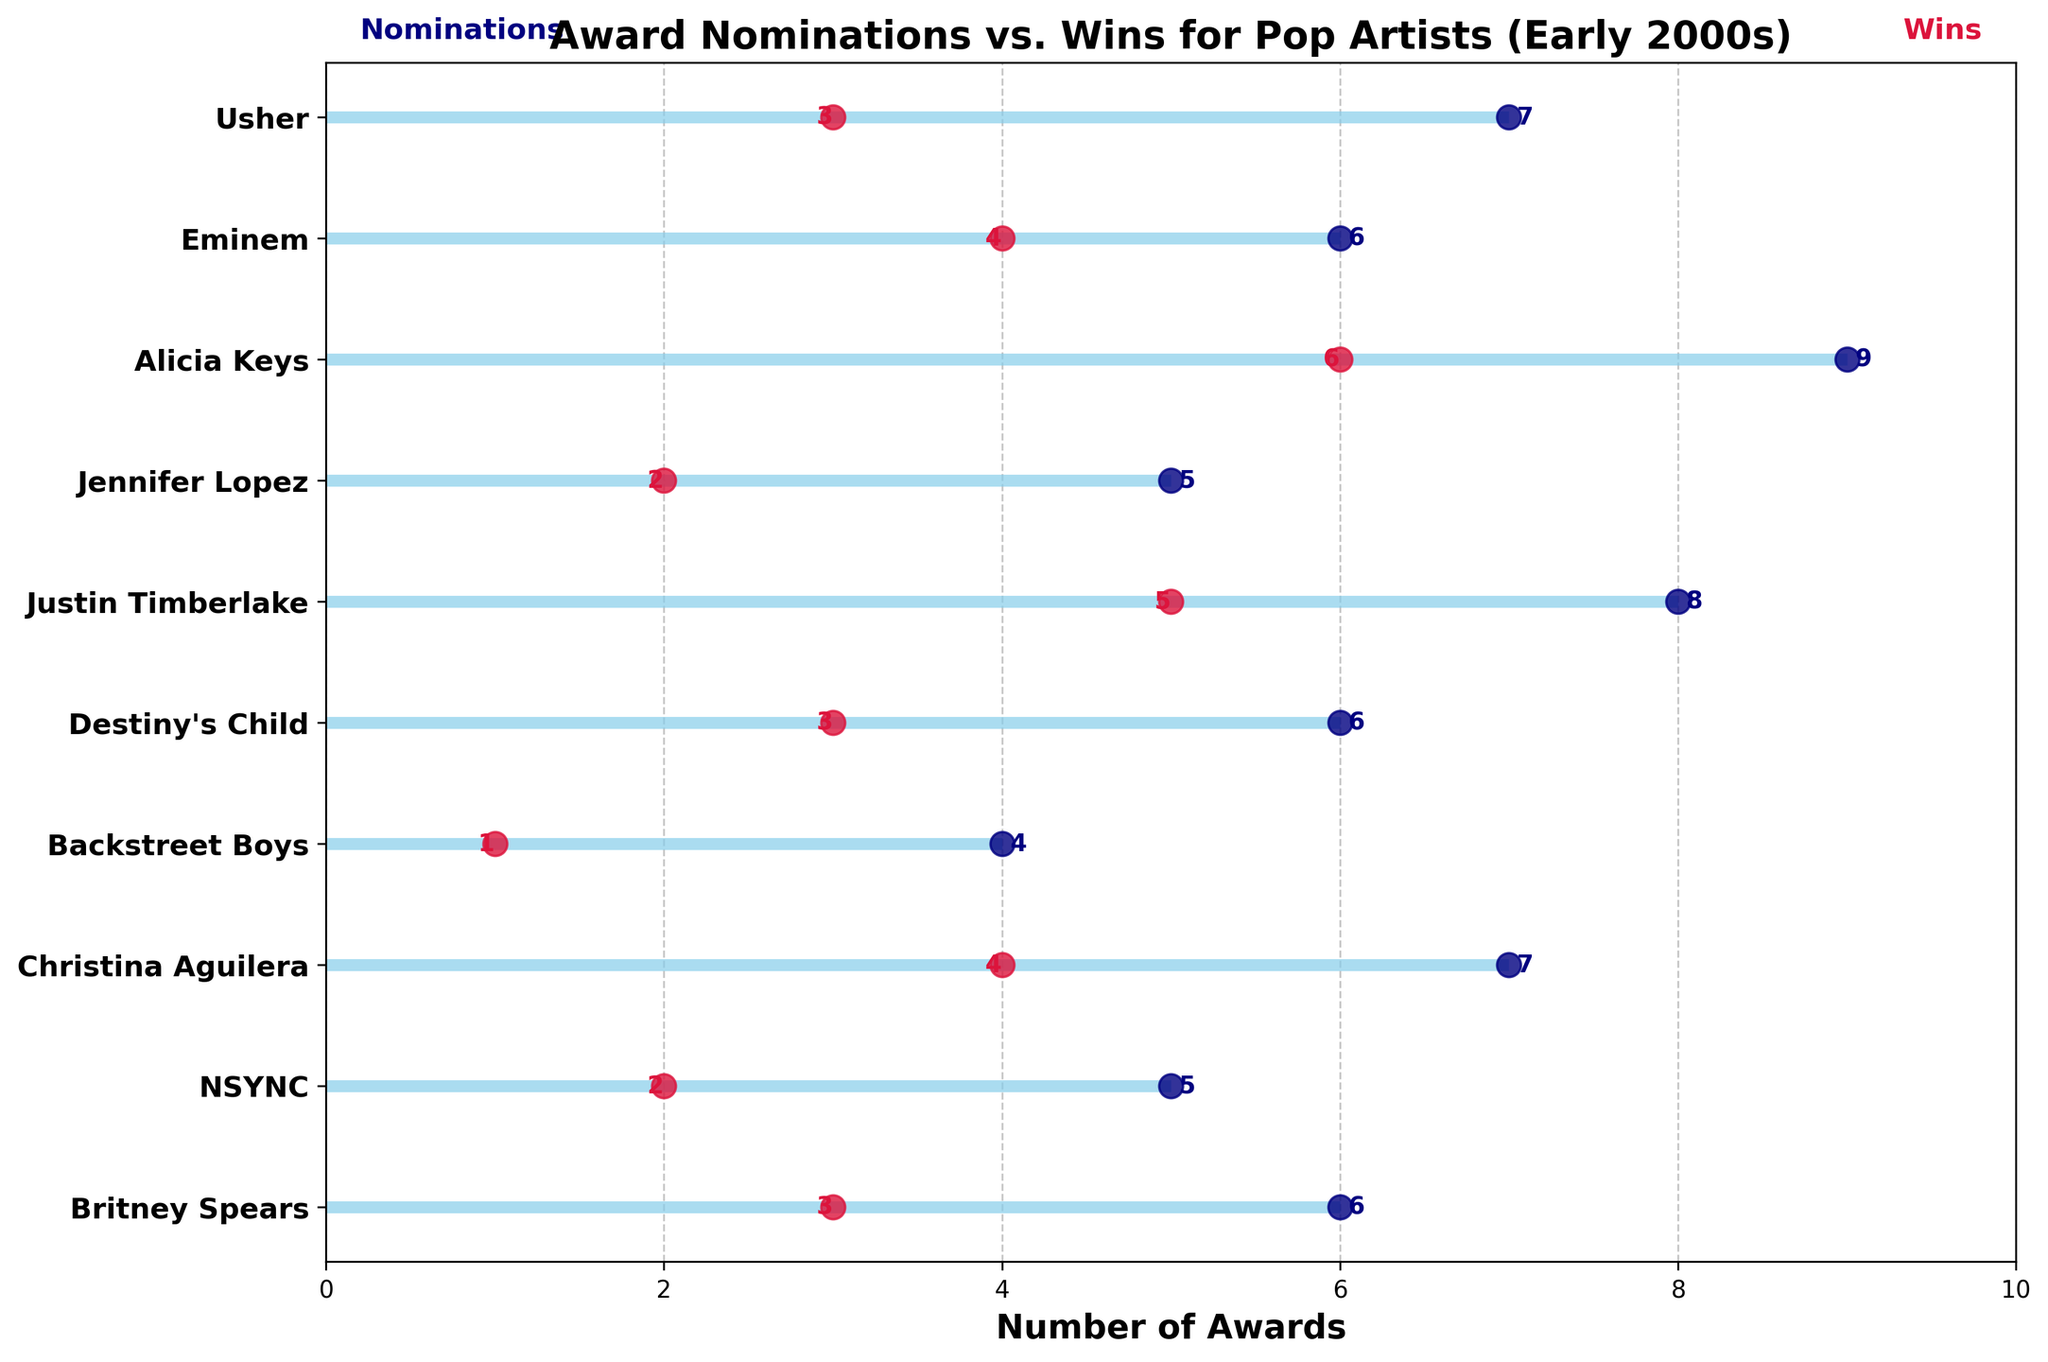What’s the title of the plot? The title is displayed at the top of the figure in bold letters. By simply looking there, you can read the title.
Answer: "Award Nominations vs. Wins for Pop Artists (Early 2000s)" Which artist had the highest number of wins? By comparing the number of wins (represented by crimson dots) for all artists, you can see that Alicia Keys' dot is placed highest, indicating the most wins.
Answer: Alicia Keys How many nominations did Justin Timberlake receive? Look for Justin Timberlake's name on the y-axis, and then trace horizontally to see his nomination count on the x-axis, marked by a navy-colored dot.
Answer: 8 Which artist had fewer wins: NSYNC or Usher? Locate the crimson dots for both NSYNC and Usher. USher's dot shows 3 wins and NSYNC's dot shows 2 wins.
Answer: NSYNC What is the difference in nominations between Britney Spears and Christina Aguilera? Find the navy dots for both Britney Spears and Christina Aguilera, read their nomination counts (6 and 7 respectively), and subtract to find the difference.
Answer: 1 How many total nominations do all artists have together? Sum the number of nominations for all listed artists: 6 + 5 + 7 + 4 + 6 + 8 + 5 + 9 + 6 + 7.
Answer: 63 Which artist had a nominations-to-wins ratio of 1:1? Compare the navy (nominations) and crimson (wins) dots for each artist. Those with equal positions for both dots would have a 1:1 ratio. None of the artists have equal counts of nominations and wins.
Answer: None How many more wins did Alicia Keys have compared to Destiny's Child? Alicia Keys had 6 wins, and Destiny's Child had 3 wins. Subtract Destiny's Child's wins from Alicia Keys'.
Answer: 3 Which artist won half of their nominations? Look for an artist whose crimson dot (win) count is half of their navy dot (nomination) count. Britney Spears, with 3 wins out of 6 nominations, fits this criterion.
Answer: Britney Spears Who won more awards: Eminem or NSYNC? Compare the positions of the crimson dots representing wins for Eminem and NSYNC. Eminem's dot shows 4 wins, and NSYNC's dot shows 2 wins.
Answer: Eminem 